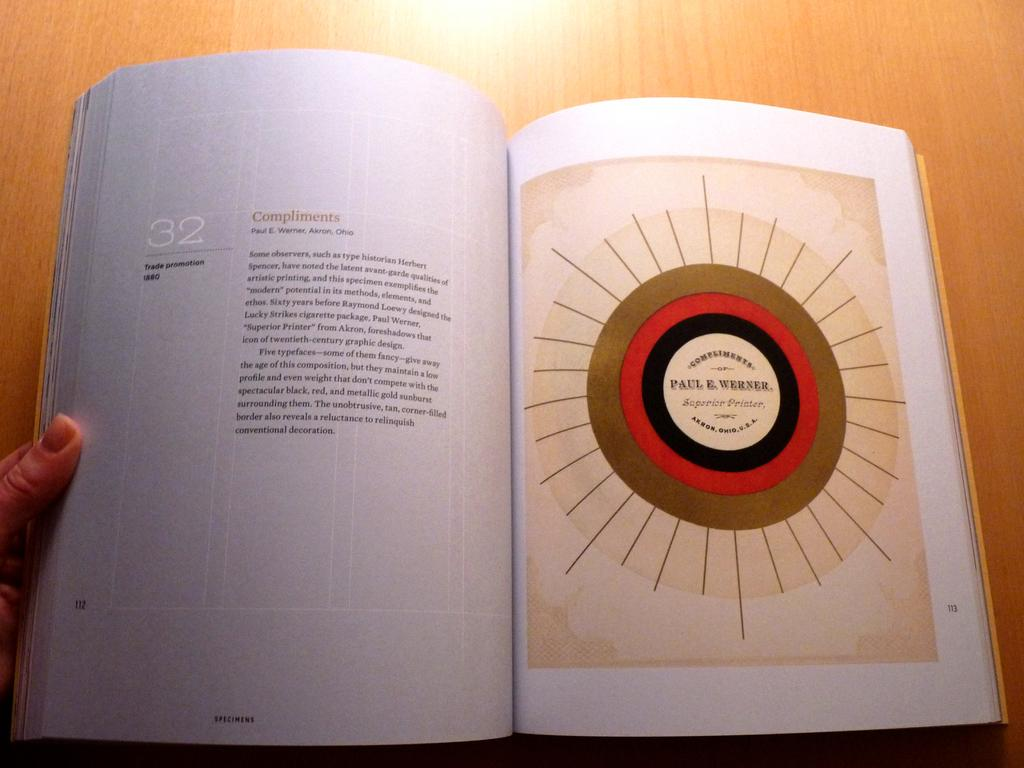<image>
Present a compact description of the photo's key features. A person is reading a book that is open to page 112, chapter 32. 